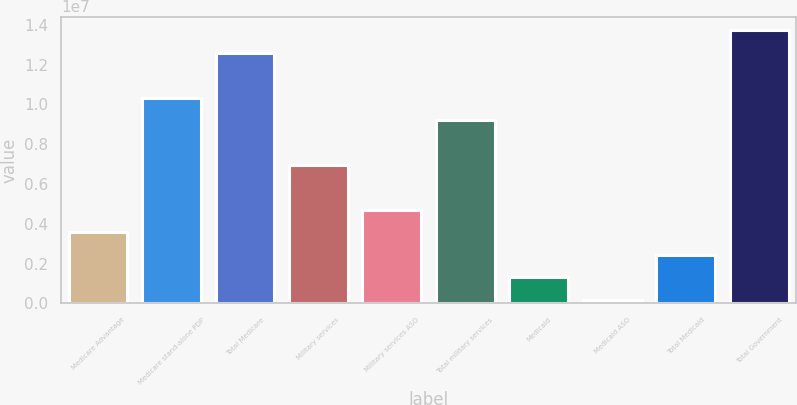Convert chart to OTSL. <chart><loc_0><loc_0><loc_500><loc_500><bar_chart><fcel>Medicare Advantage<fcel>Medicare stand-alone PDP<fcel>Total Medicare<fcel>Military services<fcel>Military services ASO<fcel>Total military services<fcel>Medicaid<fcel>Medicaid ASO<fcel>Total Medicaid<fcel>Total Government<nl><fcel>3.56667e+06<fcel>1.03388e+07<fcel>1.25962e+07<fcel>6.95274e+06<fcel>4.69536e+06<fcel>9.21012e+06<fcel>1.30929e+06<fcel>180600<fcel>2.43798e+06<fcel>1.37249e+07<nl></chart> 